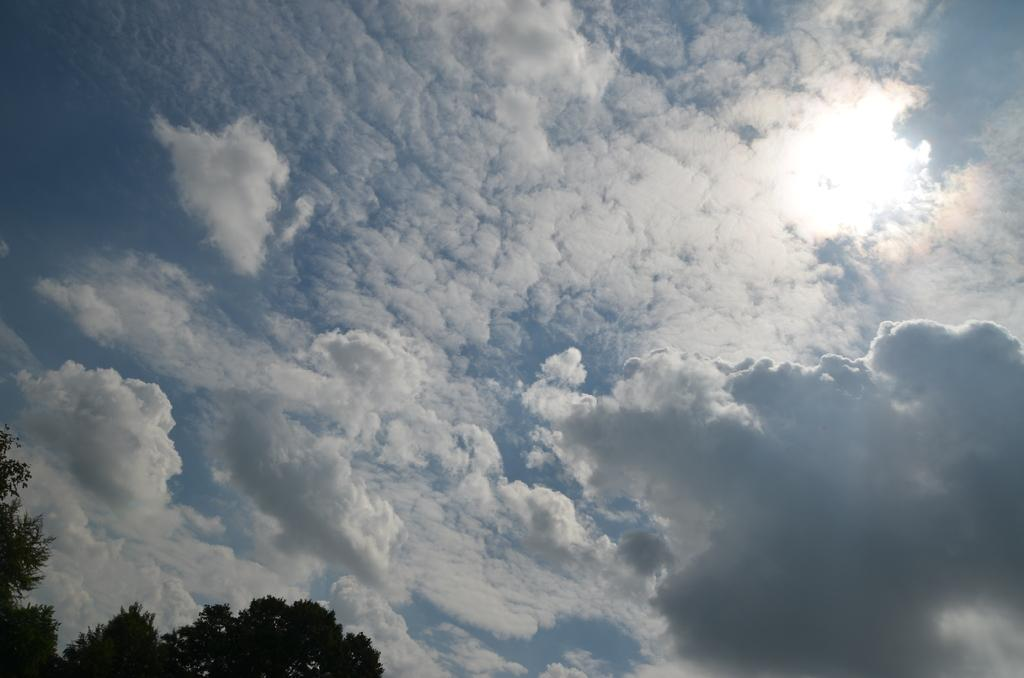What type of vegetation is present in the image? There is a group of trees in the image. What can be seen in the background of the image? The sky is visible in the background of the image. How would you describe the sky in the image? The sky appears to be cloudy. What type of advertisement can be seen on the farm in the image? There is no farm or advertisement present in the image; it features a group of trees and a cloudy sky. Can you describe the type of ray that is visible in the image? There is no ray visible in the image. 